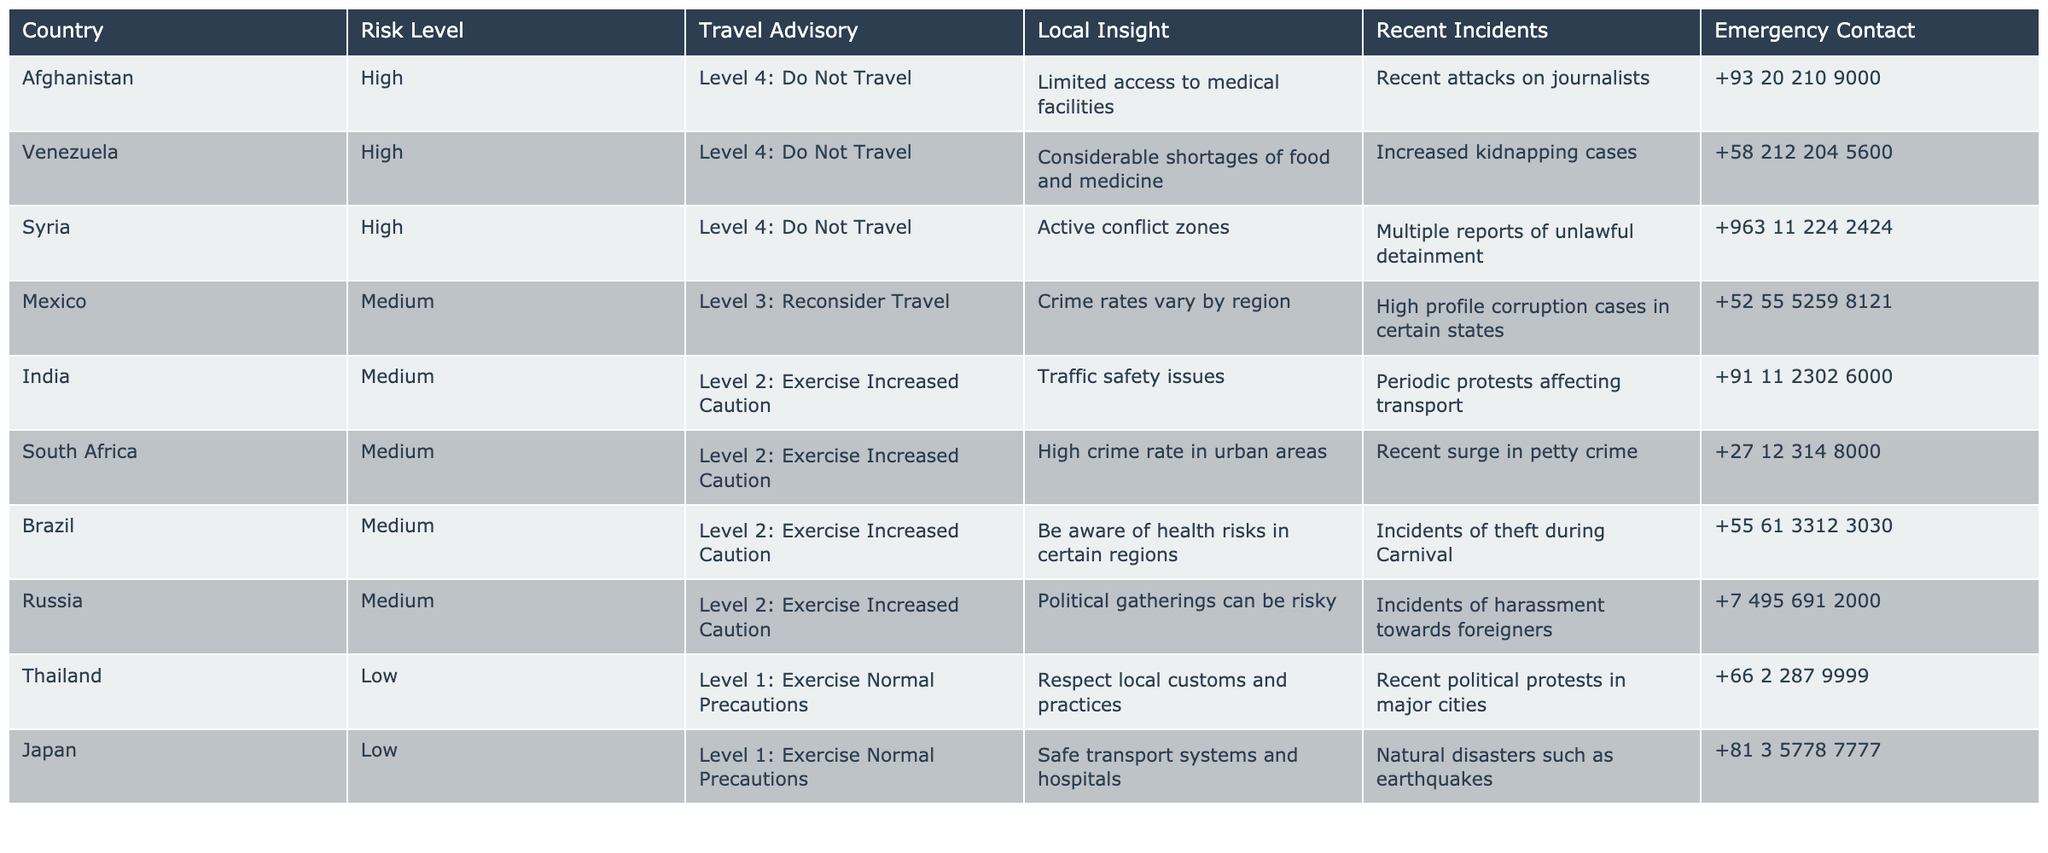What is the risk level for Afghanistan? The table shows the risk level for Afghanistan listed under the "Risk Level" column, which states "High."
Answer: High Which country has the lowest travel advisory level? Looking at the "Travel Advisory" column, the countries with the lowest level (Level 1: Exercise Normal Precautions) are Thailand and Japan.
Answer: Thailand and Japan Are there any recent incidents reported in Venezuela? The "Recent Incidents" column indicates there are increased kidnapping cases in Venezuela.
Answer: Yes What is the emergency contact number for Mexico? The "Emergency Contact" column provides the emergency contact number for Mexico as "+52 55 5259 8121."
Answer: +52 55 5259 8121 How many countries have a medium risk level? There are a total of 4 countries with a medium risk level (Mexico, India, South Africa, Brazil, and Russia), which can be counted from the "Risk Level" column.
Answer: 5 Which country has the highest crime rates mentioned in the local insight? The "Local Insight" for South Africa mentions a high crime rate in urban areas, which indicates it has the highest crime concern compared to others in the table.
Answer: South Africa Is it true that Syria has a recent attack on journalists? The "Recent Incidents" column states there have been multiple reports of unlawful detainment in Syria, indicating serious threats to local safety. The specific mention of attacks on journalists is not present; therefore, it leads to a "false" conclusion based on the fact presented.
Answer: False Which country's recent incidents involve natural disasters? The "Recent Incidents" for Japan mentions natural disasters such as earthquakes, indicating it experiences such incidents.
Answer: Japan How do the emergency contact numbers for high-risk countries compare with low-risk countries? High-risk countries like Afghanistan, Venezuela, and Syria have emergency contacts, while low-risk countries such as Thailand and Japan also have provided numbers; however, the focus should be on the context of risks rather than simply comparing numbers without context.
Answer: They provide contact numbers, but the risks vary significantly Calculate the average risk level across all countries in the table. The countries are categorized into High (3 countries), Medium (5 countries), and Low (2 countries). The average risk level cannot be numerically calculated as it is categorical; however, more high-risk countries exist than low or medium levels.
Answer: Cannot be numerically averaged 